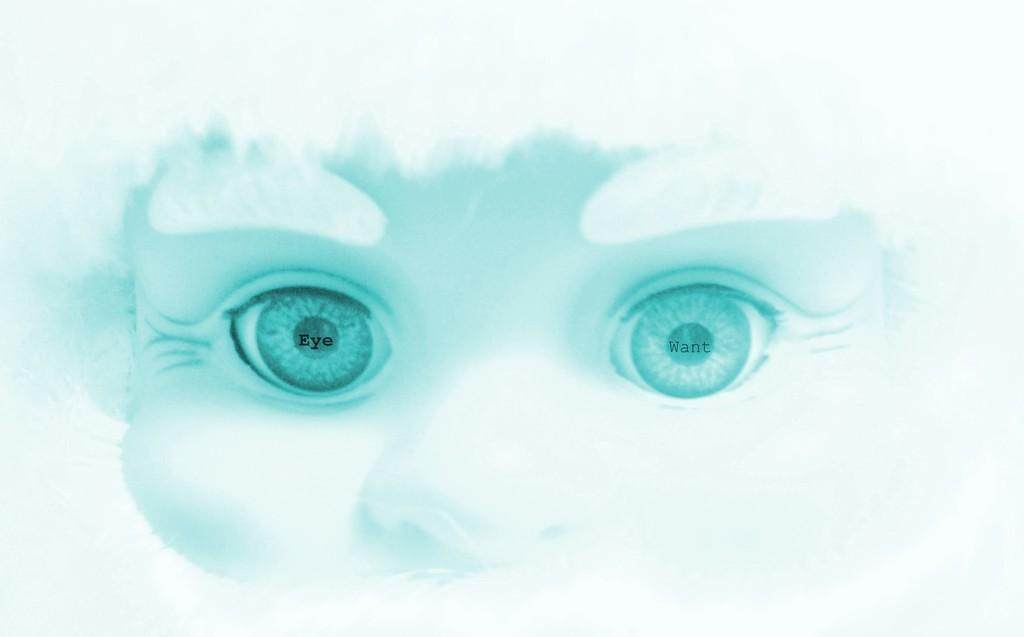What is the main subject of the image? There is a person in the image. What type of club is the person holding in the image? There is no club present in the image; it only features a person. 